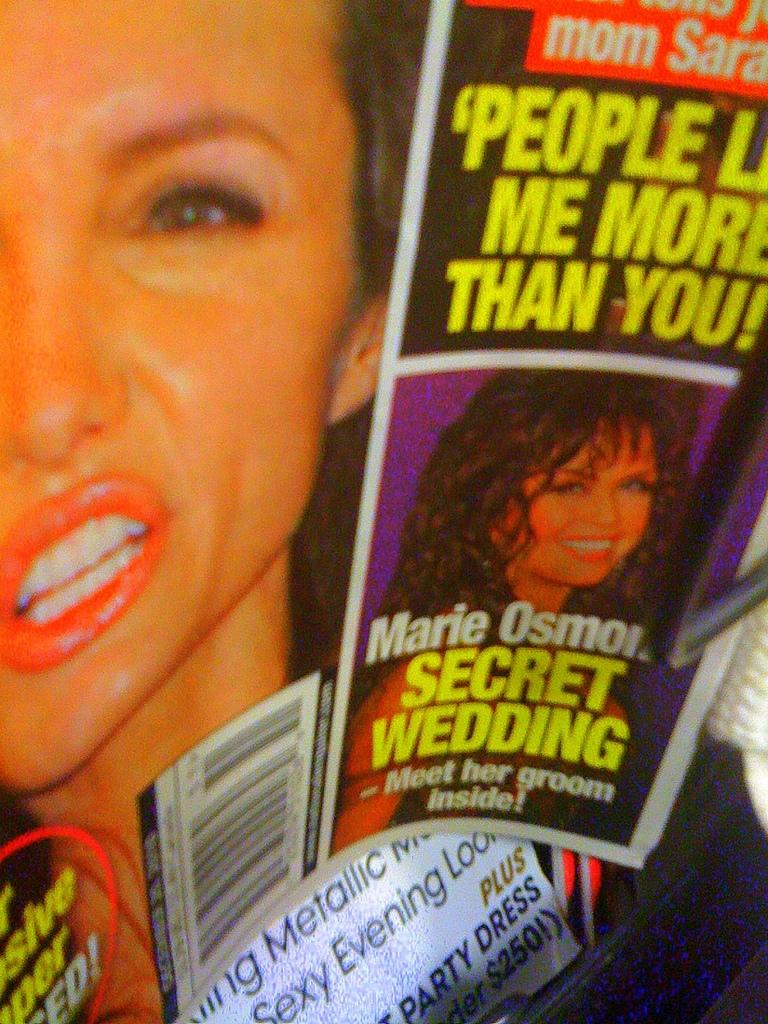<image>
Offer a succinct explanation of the picture presented. A tabloid advertises an article about Marie Osmond's "Secret wedding". 